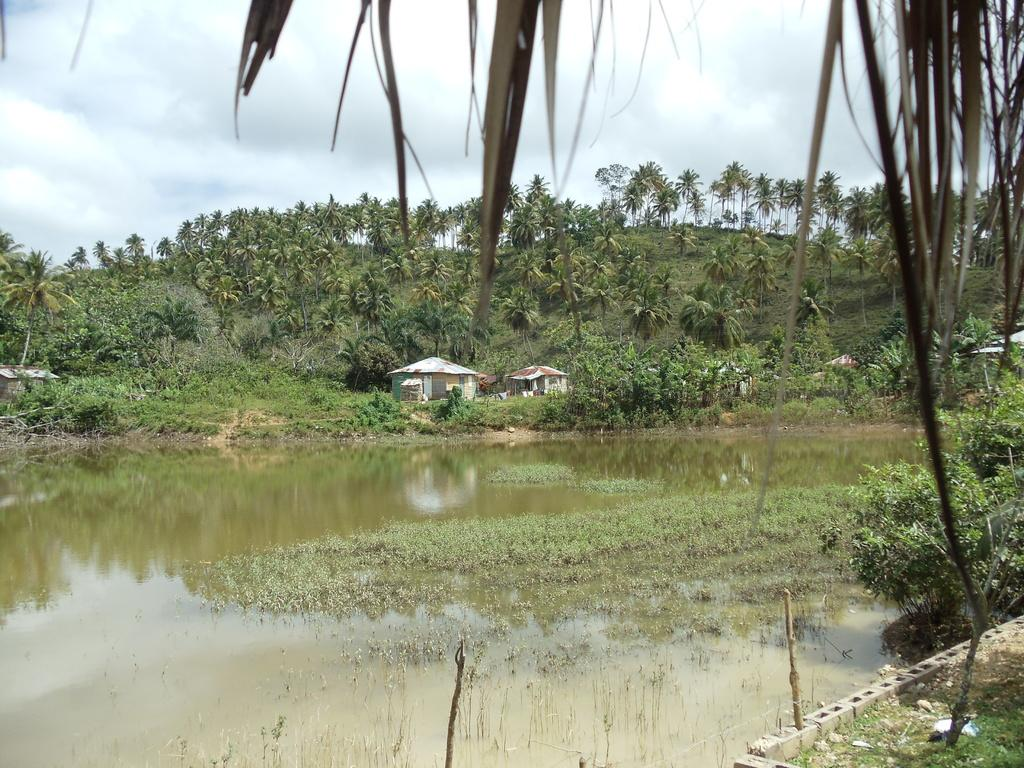What type of water body is present in the image? There is a pond in the image. What can be seen behind the pond? Grassy land is visible behind the pond. What is present in the background of the image? Trees and a hut are present in the background of the image. How would you describe the sky in the image? The sky is cloudy in the image. What type of map is being used to navigate the pond in the image? There is no map present in the image, and the pond is not being navigated. 